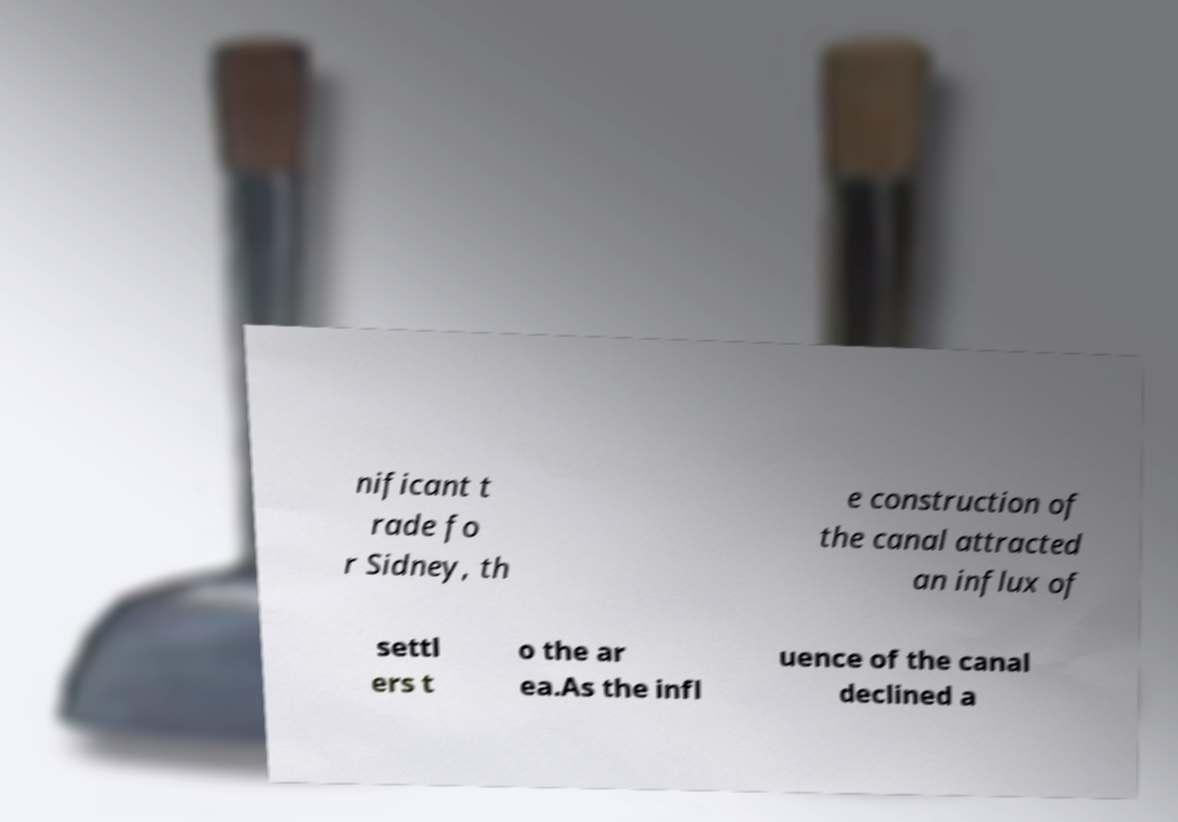Please identify and transcribe the text found in this image. nificant t rade fo r Sidney, th e construction of the canal attracted an influx of settl ers t o the ar ea.As the infl uence of the canal declined a 